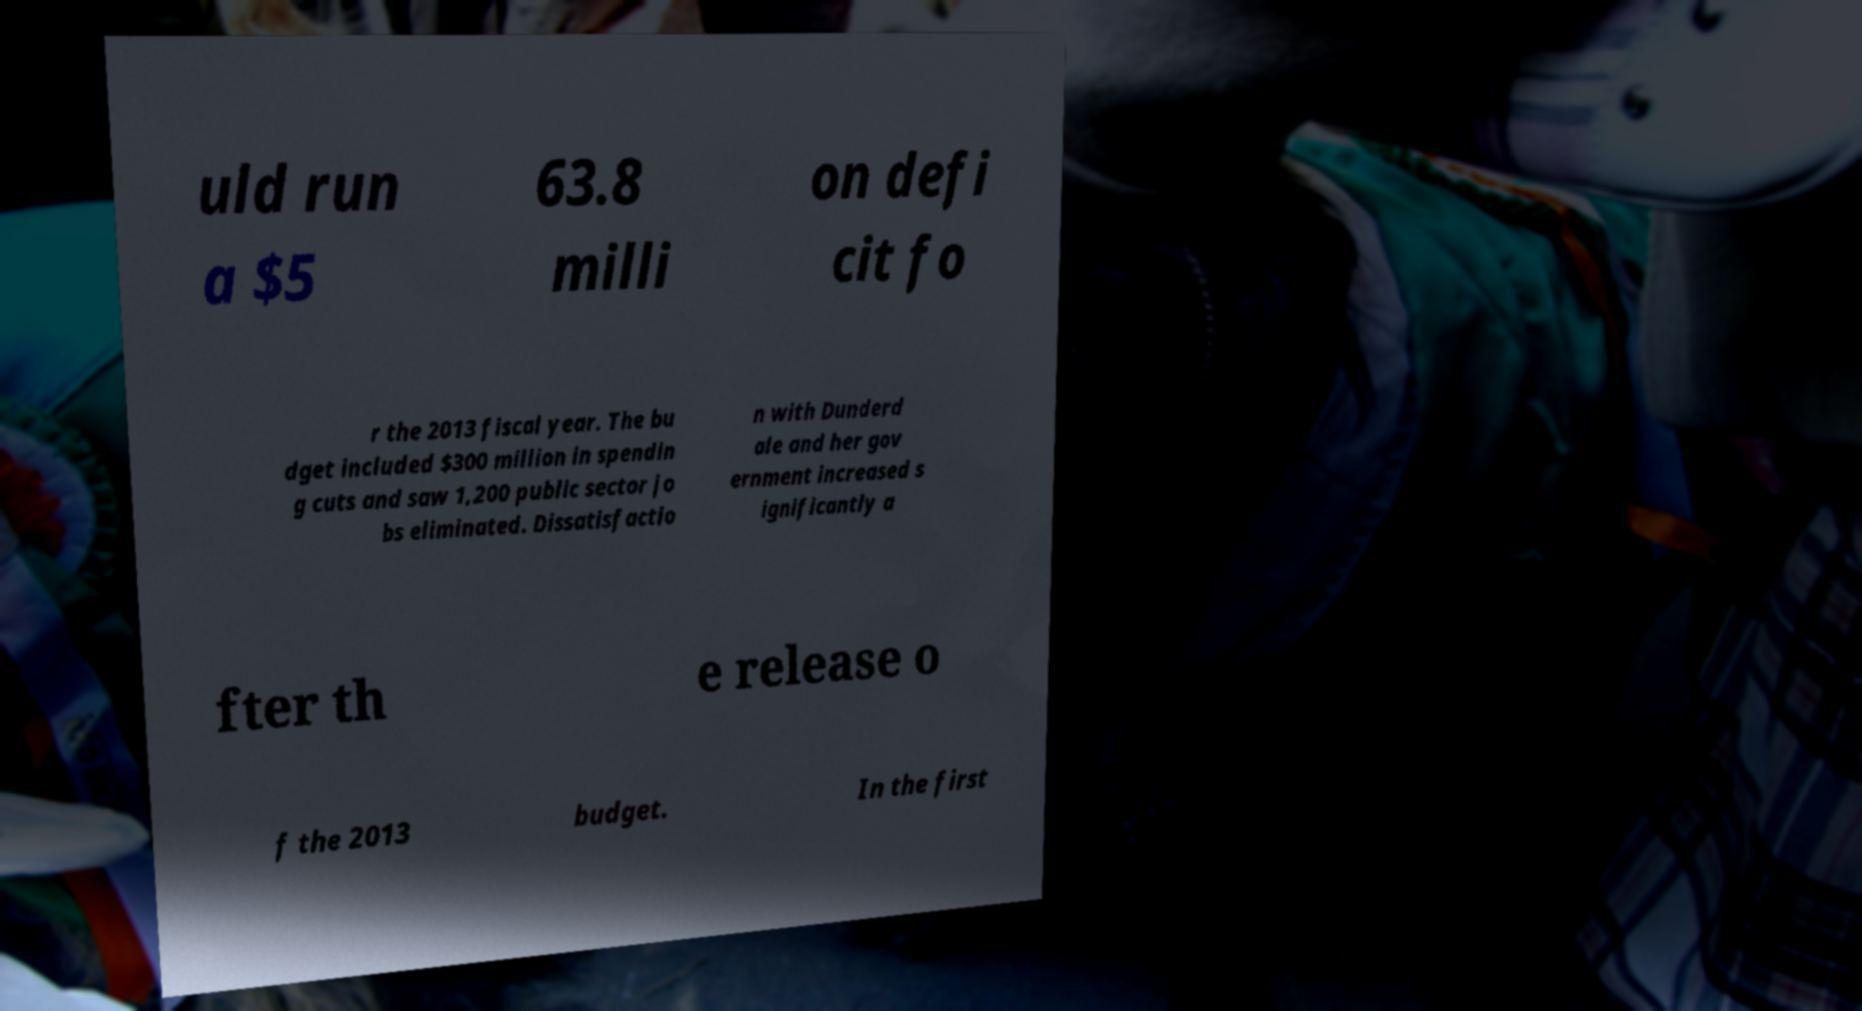Can you accurately transcribe the text from the provided image for me? uld run a $5 63.8 milli on defi cit fo r the 2013 fiscal year. The bu dget included $300 million in spendin g cuts and saw 1,200 public sector jo bs eliminated. Dissatisfactio n with Dunderd ale and her gov ernment increased s ignificantly a fter th e release o f the 2013 budget. In the first 